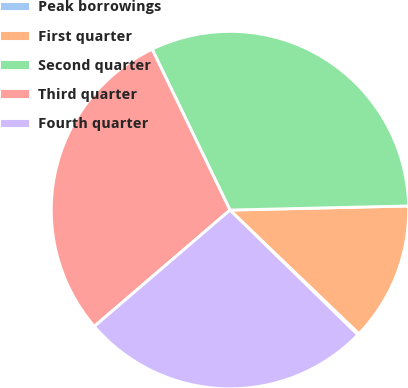Convert chart to OTSL. <chart><loc_0><loc_0><loc_500><loc_500><pie_chart><fcel>Peak borrowings<fcel>First quarter<fcel>Second quarter<fcel>Third quarter<fcel>Fourth quarter<nl><fcel>0.14%<fcel>12.53%<fcel>31.81%<fcel>29.11%<fcel>26.42%<nl></chart> 